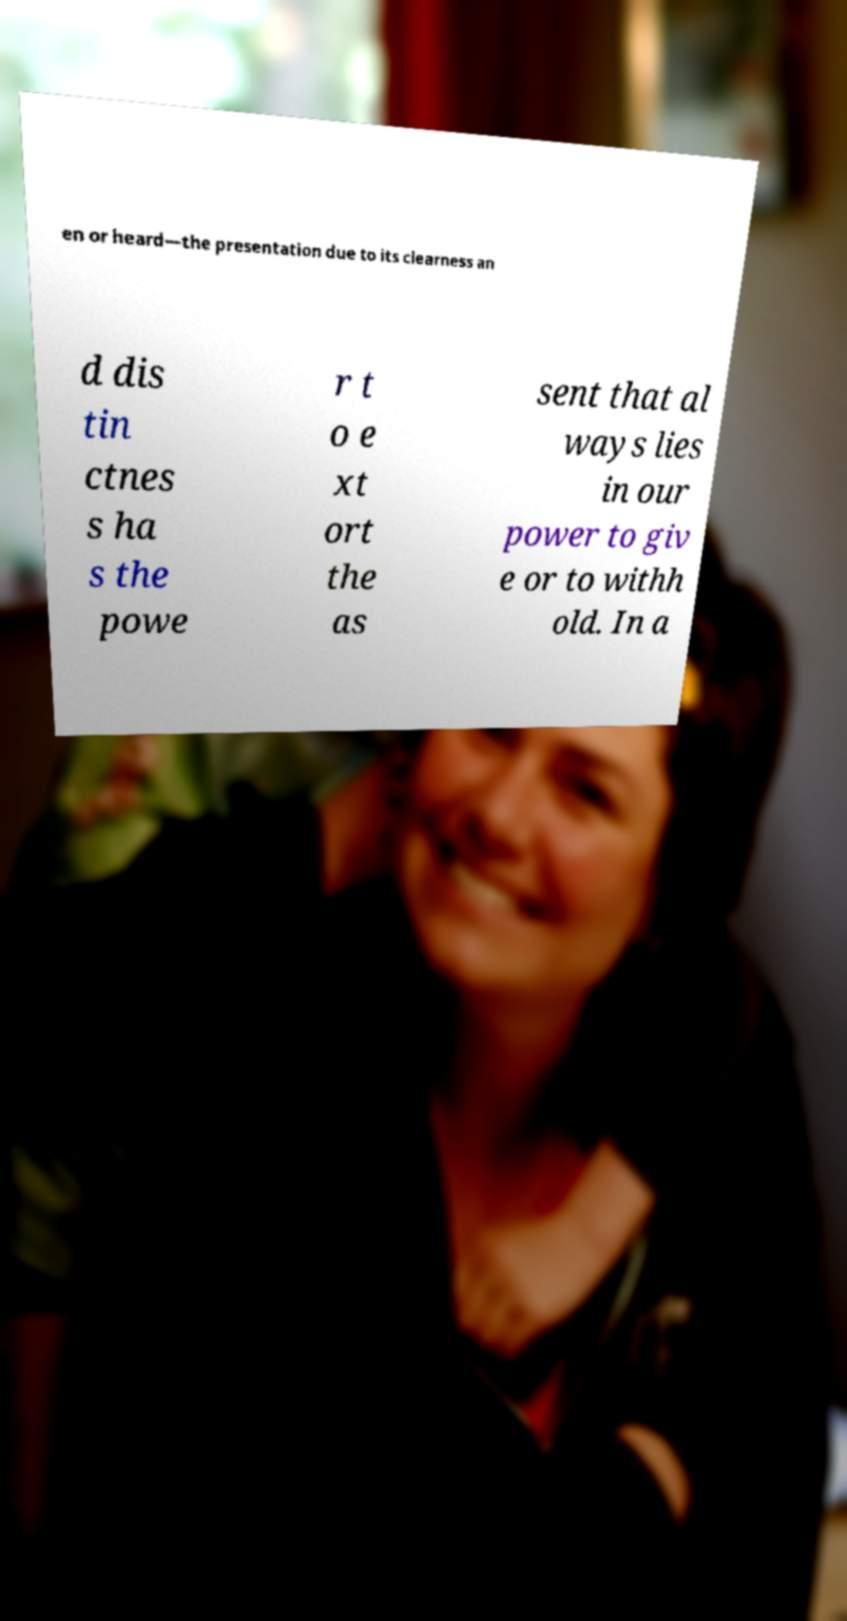For documentation purposes, I need the text within this image transcribed. Could you provide that? en or heard—the presentation due to its clearness an d dis tin ctnes s ha s the powe r t o e xt ort the as sent that al ways lies in our power to giv e or to withh old. In a 